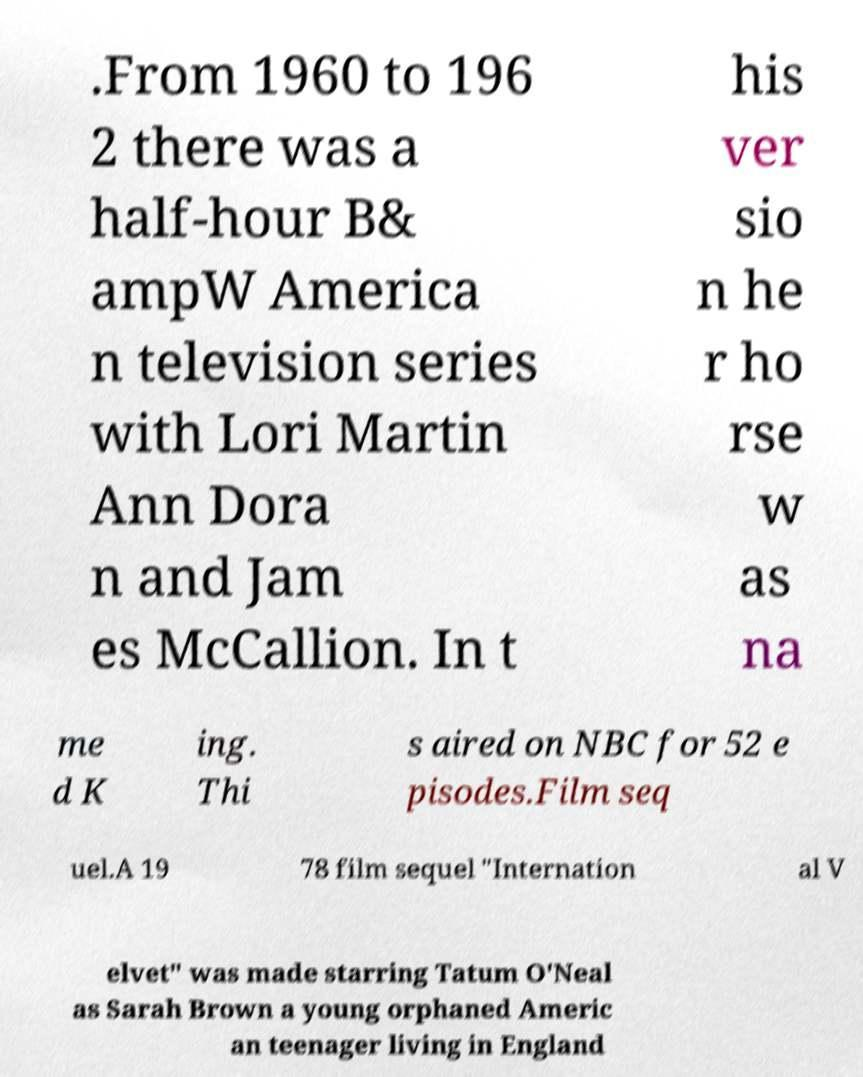Please read and relay the text visible in this image. What does it say? .From 1960 to 196 2 there was a half-hour B& ampW America n television series with Lori Martin Ann Dora n and Jam es McCallion. In t his ver sio n he r ho rse w as na me d K ing. Thi s aired on NBC for 52 e pisodes.Film seq uel.A 19 78 film sequel "Internation al V elvet" was made starring Tatum O'Neal as Sarah Brown a young orphaned Americ an teenager living in England 